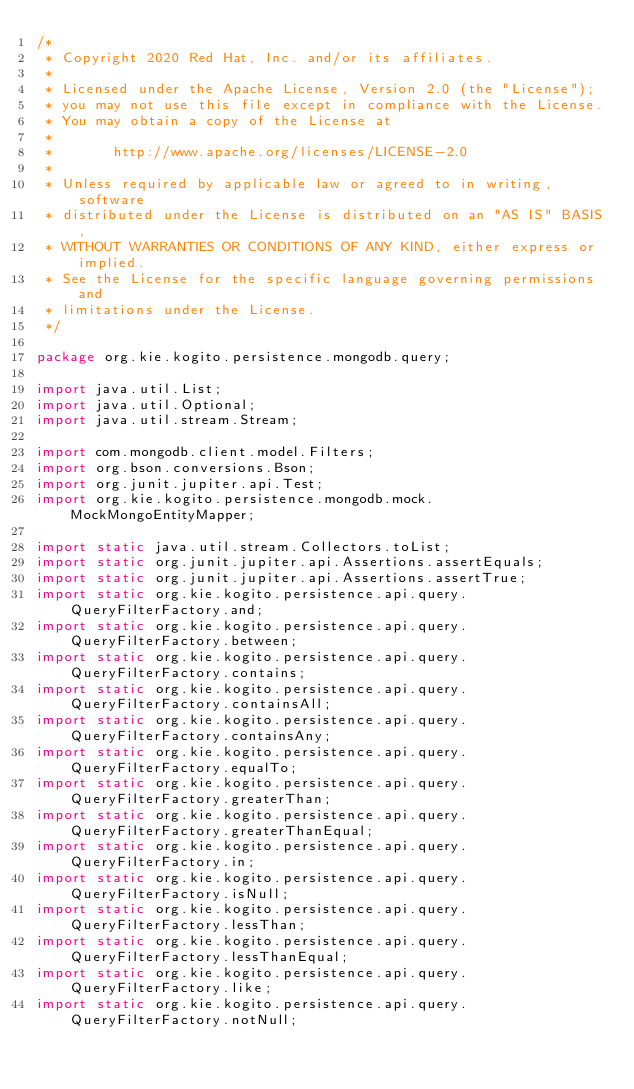<code> <loc_0><loc_0><loc_500><loc_500><_Java_>/*
 * Copyright 2020 Red Hat, Inc. and/or its affiliates.
 *
 * Licensed under the Apache License, Version 2.0 (the "License");
 * you may not use this file except in compliance with the License.
 * You may obtain a copy of the License at
 *
 *       http://www.apache.org/licenses/LICENSE-2.0
 *
 * Unless required by applicable law or agreed to in writing, software
 * distributed under the License is distributed on an "AS IS" BASIS,
 * WITHOUT WARRANTIES OR CONDITIONS OF ANY KIND, either express or implied.
 * See the License for the specific language governing permissions and
 * limitations under the License.
 */

package org.kie.kogito.persistence.mongodb.query;

import java.util.List;
import java.util.Optional;
import java.util.stream.Stream;

import com.mongodb.client.model.Filters;
import org.bson.conversions.Bson;
import org.junit.jupiter.api.Test;
import org.kie.kogito.persistence.mongodb.mock.MockMongoEntityMapper;

import static java.util.stream.Collectors.toList;
import static org.junit.jupiter.api.Assertions.assertEquals;
import static org.junit.jupiter.api.Assertions.assertTrue;
import static org.kie.kogito.persistence.api.query.QueryFilterFactory.and;
import static org.kie.kogito.persistence.api.query.QueryFilterFactory.between;
import static org.kie.kogito.persistence.api.query.QueryFilterFactory.contains;
import static org.kie.kogito.persistence.api.query.QueryFilterFactory.containsAll;
import static org.kie.kogito.persistence.api.query.QueryFilterFactory.containsAny;
import static org.kie.kogito.persistence.api.query.QueryFilterFactory.equalTo;
import static org.kie.kogito.persistence.api.query.QueryFilterFactory.greaterThan;
import static org.kie.kogito.persistence.api.query.QueryFilterFactory.greaterThanEqual;
import static org.kie.kogito.persistence.api.query.QueryFilterFactory.in;
import static org.kie.kogito.persistence.api.query.QueryFilterFactory.isNull;
import static org.kie.kogito.persistence.api.query.QueryFilterFactory.lessThan;
import static org.kie.kogito.persistence.api.query.QueryFilterFactory.lessThanEqual;
import static org.kie.kogito.persistence.api.query.QueryFilterFactory.like;
import static org.kie.kogito.persistence.api.query.QueryFilterFactory.notNull;</code> 